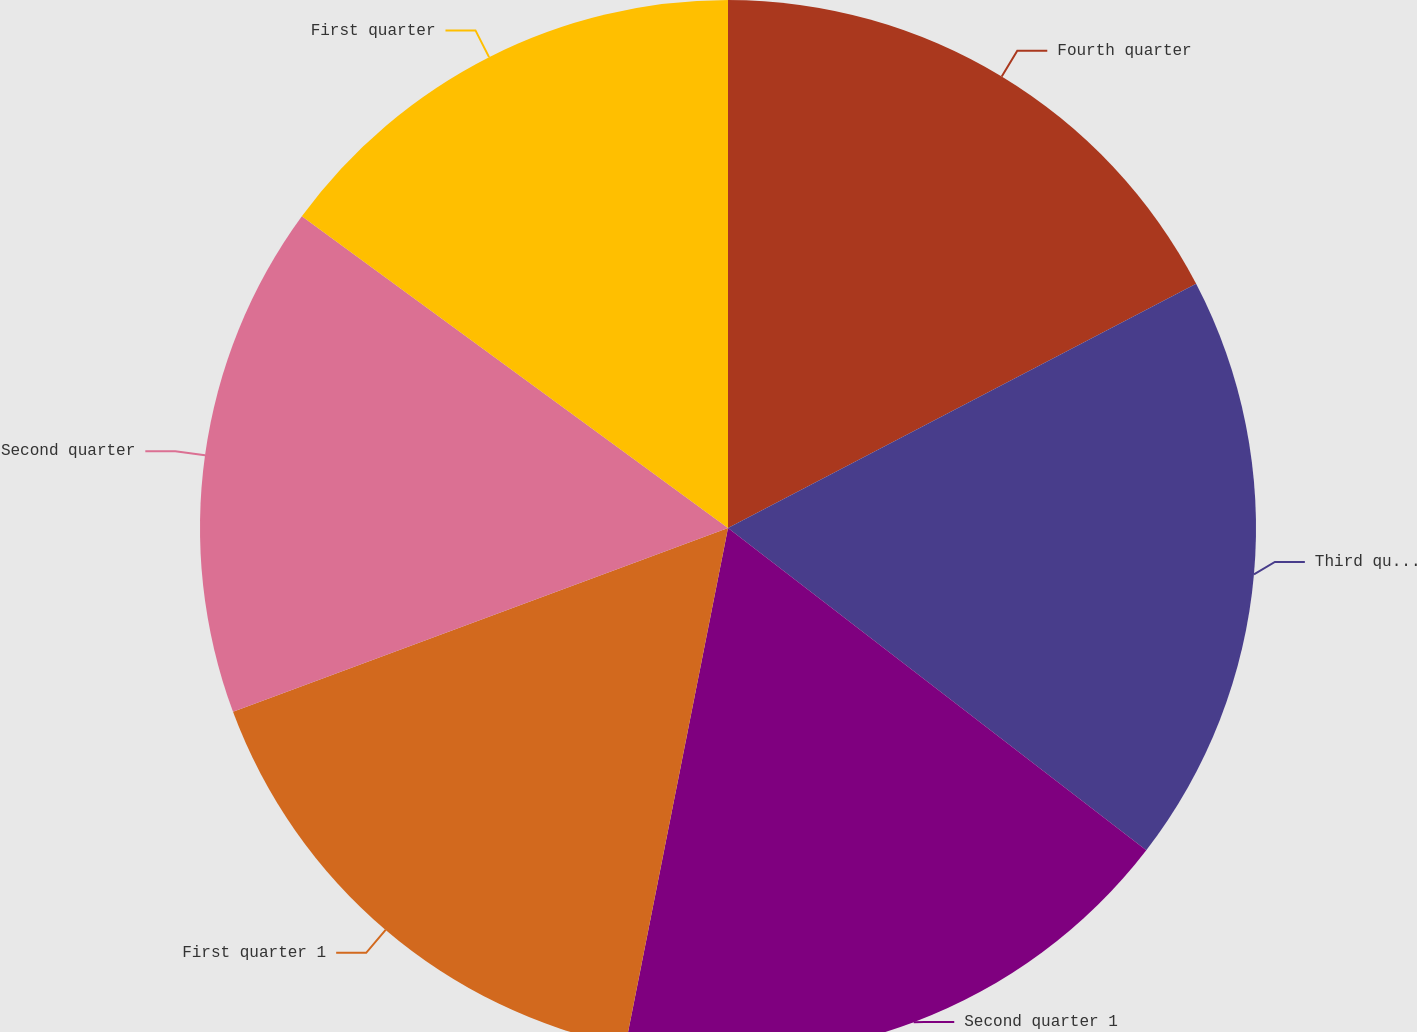Convert chart to OTSL. <chart><loc_0><loc_0><loc_500><loc_500><pie_chart><fcel>Fourth quarter<fcel>Third quarter<fcel>Second quarter 1<fcel>First quarter 1<fcel>Second quarter<fcel>First quarter<nl><fcel>17.35%<fcel>18.1%<fcel>17.67%<fcel>16.23%<fcel>15.71%<fcel>14.95%<nl></chart> 